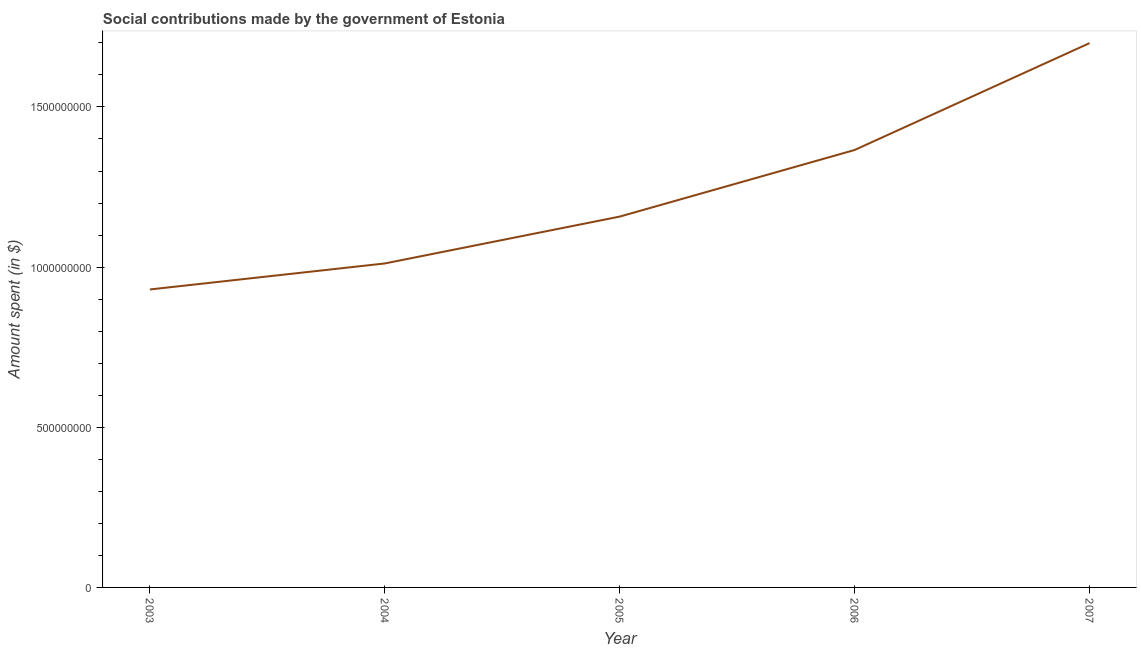What is the amount spent in making social contributions in 2003?
Give a very brief answer. 9.30e+08. Across all years, what is the maximum amount spent in making social contributions?
Offer a terse response. 1.70e+09. Across all years, what is the minimum amount spent in making social contributions?
Offer a terse response. 9.30e+08. In which year was the amount spent in making social contributions maximum?
Keep it short and to the point. 2007. In which year was the amount spent in making social contributions minimum?
Keep it short and to the point. 2003. What is the sum of the amount spent in making social contributions?
Make the answer very short. 6.16e+09. What is the difference between the amount spent in making social contributions in 2005 and 2007?
Offer a very short reply. -5.42e+08. What is the average amount spent in making social contributions per year?
Offer a very short reply. 1.23e+09. What is the median amount spent in making social contributions?
Your answer should be very brief. 1.16e+09. Do a majority of the years between 2006 and 2007 (inclusive) have amount spent in making social contributions greater than 1600000000 $?
Ensure brevity in your answer.  No. What is the ratio of the amount spent in making social contributions in 2003 to that in 2004?
Your answer should be compact. 0.92. Is the amount spent in making social contributions in 2004 less than that in 2005?
Give a very brief answer. Yes. What is the difference between the highest and the second highest amount spent in making social contributions?
Your response must be concise. 3.34e+08. Is the sum of the amount spent in making social contributions in 2003 and 2005 greater than the maximum amount spent in making social contributions across all years?
Your answer should be very brief. Yes. What is the difference between the highest and the lowest amount spent in making social contributions?
Give a very brief answer. 7.69e+08. How many lines are there?
Give a very brief answer. 1. How many years are there in the graph?
Your response must be concise. 5. What is the difference between two consecutive major ticks on the Y-axis?
Offer a very short reply. 5.00e+08. What is the title of the graph?
Your response must be concise. Social contributions made by the government of Estonia. What is the label or title of the X-axis?
Your answer should be compact. Year. What is the label or title of the Y-axis?
Provide a succinct answer. Amount spent (in $). What is the Amount spent (in $) of 2003?
Provide a succinct answer. 9.30e+08. What is the Amount spent (in $) in 2004?
Offer a very short reply. 1.01e+09. What is the Amount spent (in $) of 2005?
Offer a terse response. 1.16e+09. What is the Amount spent (in $) in 2006?
Your answer should be very brief. 1.37e+09. What is the Amount spent (in $) of 2007?
Make the answer very short. 1.70e+09. What is the difference between the Amount spent (in $) in 2003 and 2004?
Keep it short and to the point. -8.12e+07. What is the difference between the Amount spent (in $) in 2003 and 2005?
Offer a very short reply. -2.28e+08. What is the difference between the Amount spent (in $) in 2003 and 2006?
Your answer should be very brief. -4.35e+08. What is the difference between the Amount spent (in $) in 2003 and 2007?
Your answer should be compact. -7.69e+08. What is the difference between the Amount spent (in $) in 2004 and 2005?
Your answer should be compact. -1.46e+08. What is the difference between the Amount spent (in $) in 2004 and 2006?
Ensure brevity in your answer.  -3.54e+08. What is the difference between the Amount spent (in $) in 2004 and 2007?
Your answer should be compact. -6.88e+08. What is the difference between the Amount spent (in $) in 2005 and 2006?
Provide a short and direct response. -2.08e+08. What is the difference between the Amount spent (in $) in 2005 and 2007?
Give a very brief answer. -5.42e+08. What is the difference between the Amount spent (in $) in 2006 and 2007?
Keep it short and to the point. -3.34e+08. What is the ratio of the Amount spent (in $) in 2003 to that in 2004?
Offer a terse response. 0.92. What is the ratio of the Amount spent (in $) in 2003 to that in 2005?
Offer a very short reply. 0.8. What is the ratio of the Amount spent (in $) in 2003 to that in 2006?
Offer a very short reply. 0.68. What is the ratio of the Amount spent (in $) in 2003 to that in 2007?
Offer a very short reply. 0.55. What is the ratio of the Amount spent (in $) in 2004 to that in 2005?
Offer a terse response. 0.87. What is the ratio of the Amount spent (in $) in 2004 to that in 2006?
Offer a terse response. 0.74. What is the ratio of the Amount spent (in $) in 2004 to that in 2007?
Keep it short and to the point. 0.59. What is the ratio of the Amount spent (in $) in 2005 to that in 2006?
Offer a very short reply. 0.85. What is the ratio of the Amount spent (in $) in 2005 to that in 2007?
Offer a very short reply. 0.68. What is the ratio of the Amount spent (in $) in 2006 to that in 2007?
Provide a succinct answer. 0.8. 